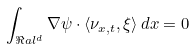<formula> <loc_0><loc_0><loc_500><loc_500>\int _ { \Re a l ^ { d } } \nabla \psi \cdot \langle \nu _ { x , t } , \xi \rangle \, d x = 0</formula> 